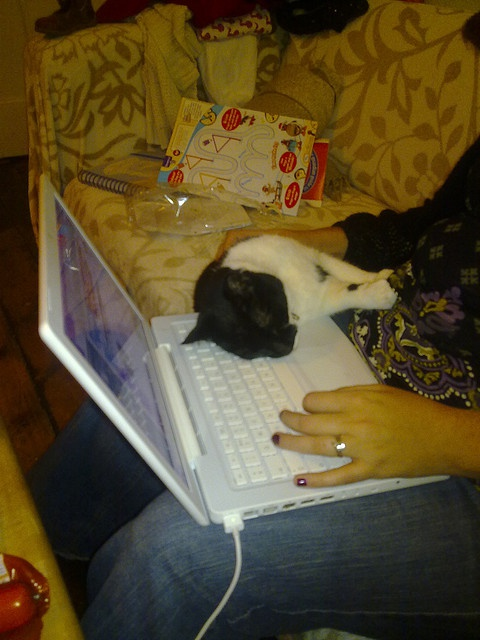Describe the objects in this image and their specific colors. I can see people in maroon, black, olive, and purple tones, couch in maroon, olive, and black tones, laptop in maroon, darkgray, gray, and beige tones, cat in maroon, black, tan, and olive tones, and book in maroon, olive, and black tones in this image. 